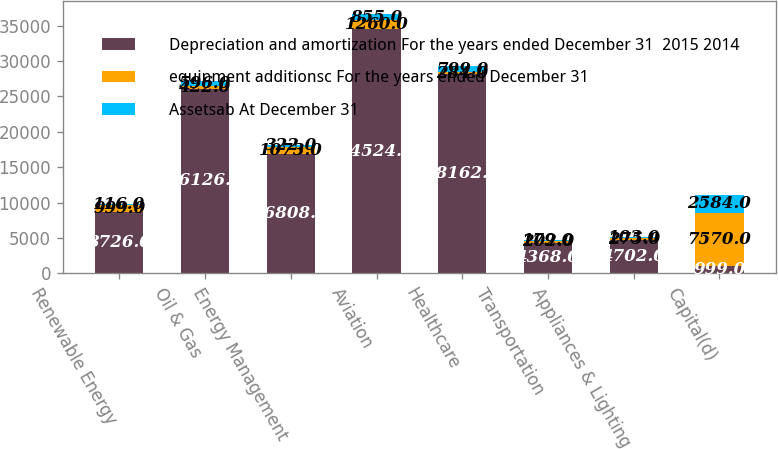Convert chart. <chart><loc_0><loc_0><loc_500><loc_500><stacked_bar_chart><ecel><fcel>Renewable Energy<fcel>Oil & Gas<fcel>Energy Management<fcel>Aviation<fcel>Healthcare<fcel>Transportation<fcel>Appliances & Lighting<fcel>Capital(d)<nl><fcel>Depreciation and amortization For the years ended December 31  2015 2014<fcel>8726<fcel>26126<fcel>16808<fcel>34524<fcel>28162<fcel>4368<fcel>4702<fcel>999<nl><fcel>equipment additionsc For the years ended December 31<fcel>999<fcel>422<fcel>1073<fcel>1260<fcel>284<fcel>202<fcel>275<fcel>7570<nl><fcel>Assetsab At December 31<fcel>116<fcel>596<fcel>322<fcel>855<fcel>799<fcel>179<fcel>103<fcel>2584<nl></chart> 